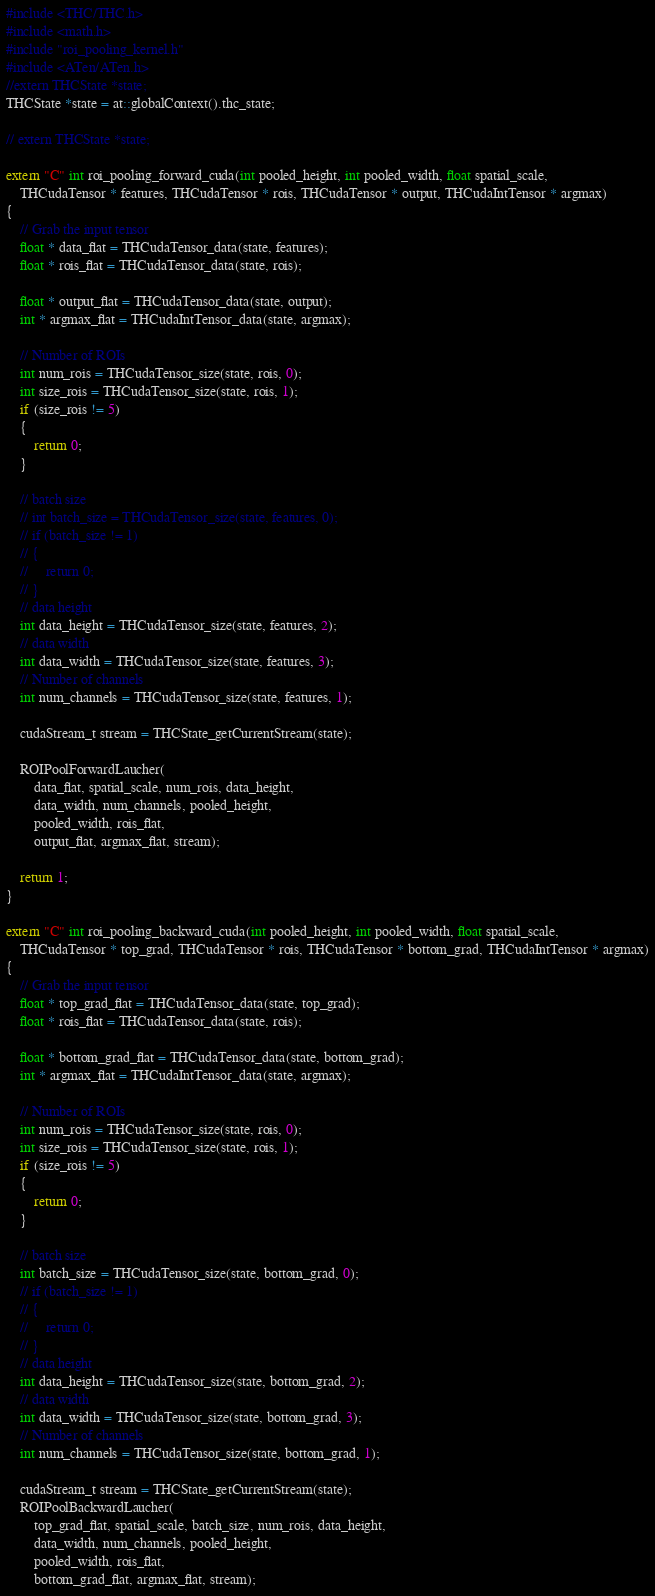<code> <loc_0><loc_0><loc_500><loc_500><_C++_>#include <THC/THC.h>
#include <math.h>
#include "roi_pooling_kernel.h"
#include <ATen/ATen.h>
//extern THCState *state;
THCState *state = at::globalContext().thc_state;

// extern THCState *state;

extern "C" int roi_pooling_forward_cuda(int pooled_height, int pooled_width, float spatial_scale,
	THCudaTensor * features, THCudaTensor * rois, THCudaTensor * output, THCudaIntTensor * argmax)
{
	// Grab the input tensor
	float * data_flat = THCudaTensor_data(state, features);
	float * rois_flat = THCudaTensor_data(state, rois);

	float * output_flat = THCudaTensor_data(state, output);
	int * argmax_flat = THCudaIntTensor_data(state, argmax);

	// Number of ROIs
	int num_rois = THCudaTensor_size(state, rois, 0);
	int size_rois = THCudaTensor_size(state, rois, 1);
	if (size_rois != 5)
	{
		return 0;
	}

	// batch size
	// int batch_size = THCudaTensor_size(state, features, 0);
	// if (batch_size != 1)
	// {
	//     return 0;
	// }
	// data height
	int data_height = THCudaTensor_size(state, features, 2);
	// data width
	int data_width = THCudaTensor_size(state, features, 3);
	// Number of channels
	int num_channels = THCudaTensor_size(state, features, 1);

	cudaStream_t stream = THCState_getCurrentStream(state);

	ROIPoolForwardLaucher(
		data_flat, spatial_scale, num_rois, data_height,
		data_width, num_channels, pooled_height,
		pooled_width, rois_flat,
		output_flat, argmax_flat, stream);

	return 1;
}

extern "C" int roi_pooling_backward_cuda(int pooled_height, int pooled_width, float spatial_scale,
	THCudaTensor * top_grad, THCudaTensor * rois, THCudaTensor * bottom_grad, THCudaIntTensor * argmax)
{
	// Grab the input tensor
	float * top_grad_flat = THCudaTensor_data(state, top_grad);
	float * rois_flat = THCudaTensor_data(state, rois);

	float * bottom_grad_flat = THCudaTensor_data(state, bottom_grad);
	int * argmax_flat = THCudaIntTensor_data(state, argmax);

	// Number of ROIs
	int num_rois = THCudaTensor_size(state, rois, 0);
	int size_rois = THCudaTensor_size(state, rois, 1);
	if (size_rois != 5)
	{
		return 0;
	}

	// batch size
	int batch_size = THCudaTensor_size(state, bottom_grad, 0);
	// if (batch_size != 1)
	// {
	//     return 0;
	// }
	// data height
	int data_height = THCudaTensor_size(state, bottom_grad, 2);
	// data width
	int data_width = THCudaTensor_size(state, bottom_grad, 3);
	// Number of channels
	int num_channels = THCudaTensor_size(state, bottom_grad, 1);

	cudaStream_t stream = THCState_getCurrentStream(state);
	ROIPoolBackwardLaucher(
		top_grad_flat, spatial_scale, batch_size, num_rois, data_height,
		data_width, num_channels, pooled_height,
		pooled_width, rois_flat,
		bottom_grad_flat, argmax_flat, stream);
</code> 